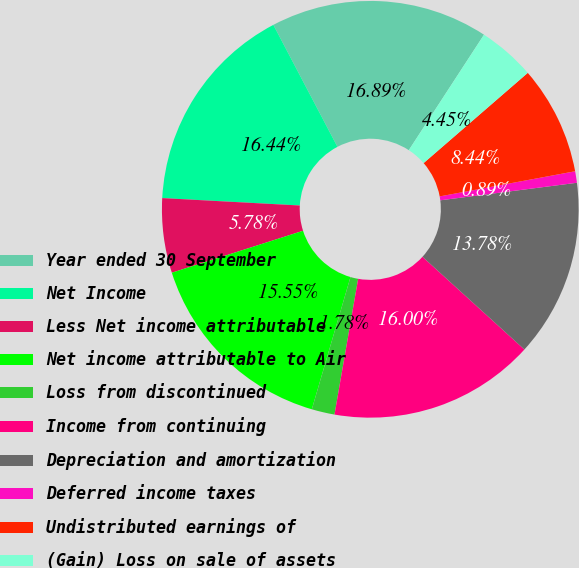Convert chart to OTSL. <chart><loc_0><loc_0><loc_500><loc_500><pie_chart><fcel>Year ended 30 September<fcel>Net Income<fcel>Less Net income attributable<fcel>Net income attributable to Air<fcel>Loss from discontinued<fcel>Income from continuing<fcel>Depreciation and amortization<fcel>Deferred income taxes<fcel>Undistributed earnings of<fcel>(Gain) Loss on sale of assets<nl><fcel>16.89%<fcel>16.44%<fcel>5.78%<fcel>15.55%<fcel>1.78%<fcel>16.0%<fcel>13.78%<fcel>0.89%<fcel>8.44%<fcel>4.45%<nl></chart> 